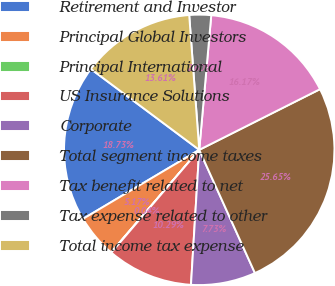Convert chart to OTSL. <chart><loc_0><loc_0><loc_500><loc_500><pie_chart><fcel>Retirement and Investor<fcel>Principal Global Investors<fcel>Principal International<fcel>US Insurance Solutions<fcel>Corporate<fcel>Total segment income taxes<fcel>Tax benefit related to net<fcel>Tax expense related to other<fcel>Total income tax expense<nl><fcel>18.73%<fcel>5.17%<fcel>0.04%<fcel>10.29%<fcel>7.73%<fcel>25.65%<fcel>16.17%<fcel>2.6%<fcel>13.61%<nl></chart> 